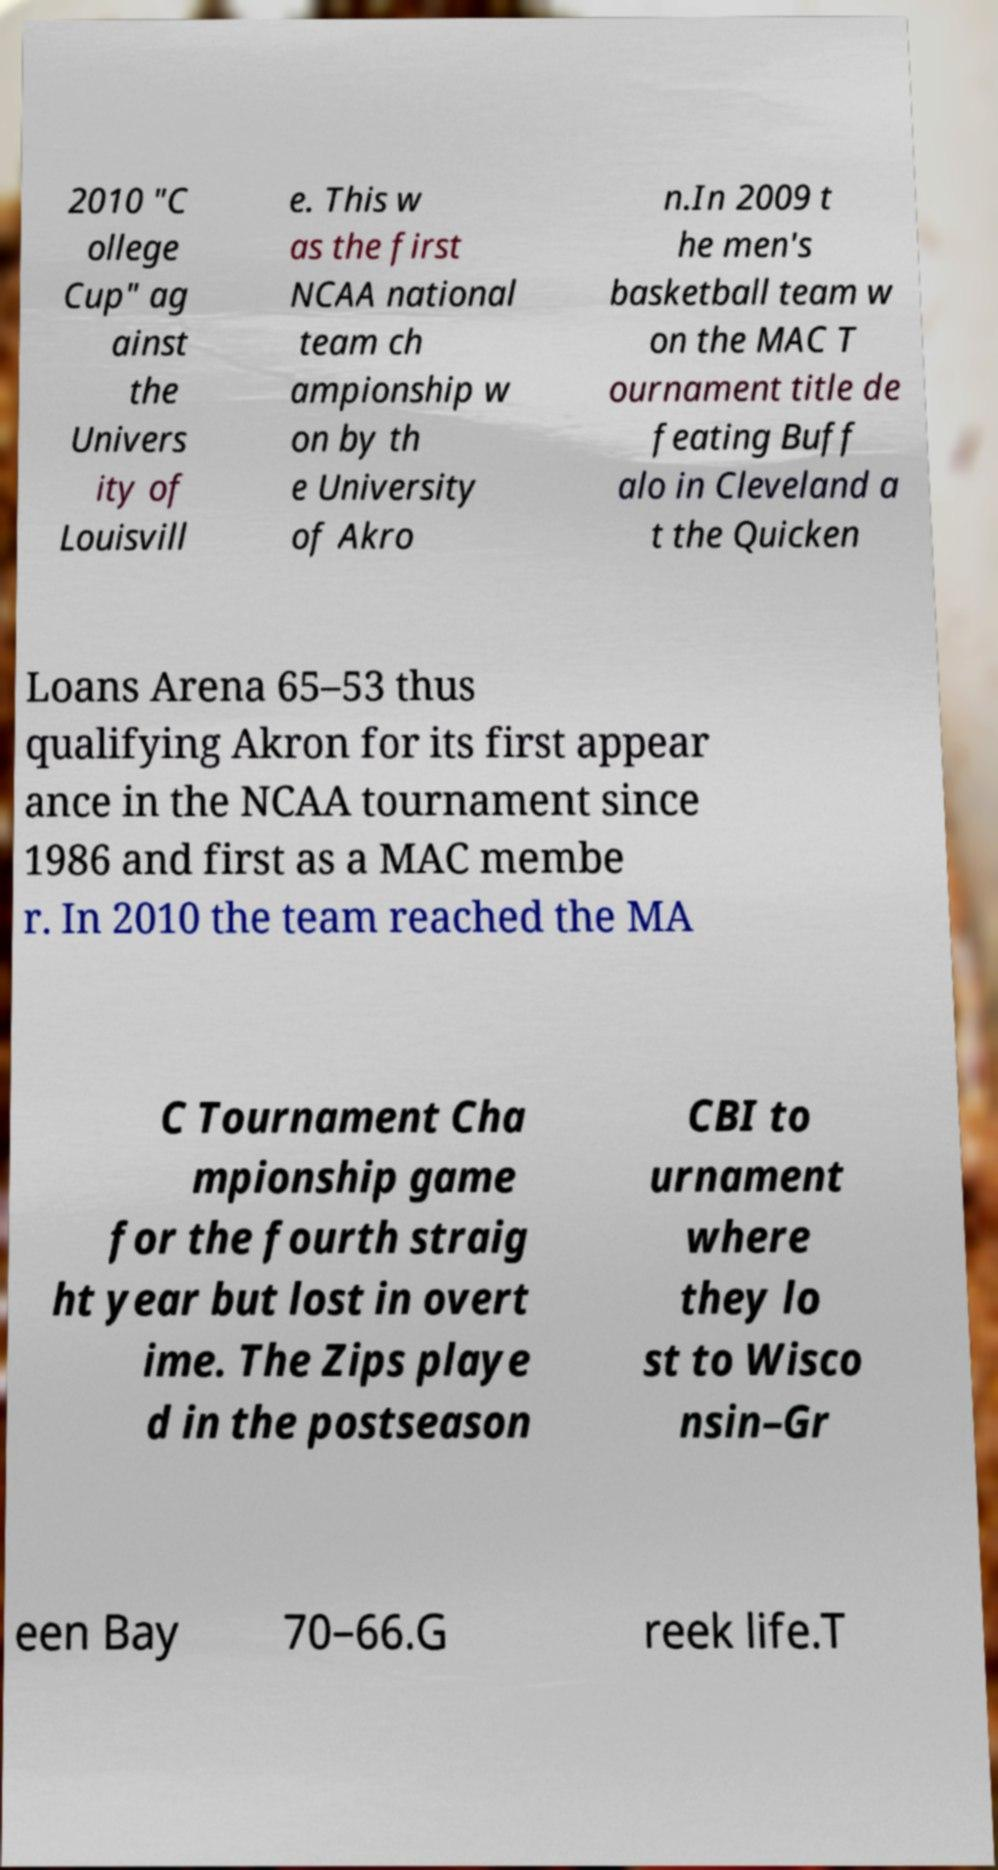There's text embedded in this image that I need extracted. Can you transcribe it verbatim? 2010 "C ollege Cup" ag ainst the Univers ity of Louisvill e. This w as the first NCAA national team ch ampionship w on by th e University of Akro n.In 2009 t he men's basketball team w on the MAC T ournament title de feating Buff alo in Cleveland a t the Quicken Loans Arena 65–53 thus qualifying Akron for its first appear ance in the NCAA tournament since 1986 and first as a MAC membe r. In 2010 the team reached the MA C Tournament Cha mpionship game for the fourth straig ht year but lost in overt ime. The Zips playe d in the postseason CBI to urnament where they lo st to Wisco nsin–Gr een Bay 70–66.G reek life.T 